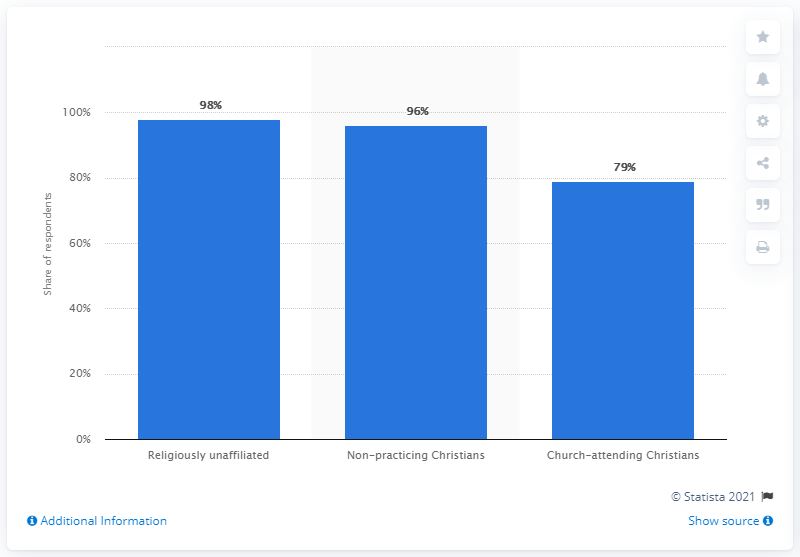Draw attention to some important aspects in this diagram. In 2017, a majority of Swedish respondents, or 98%, were in favor of abortion. 